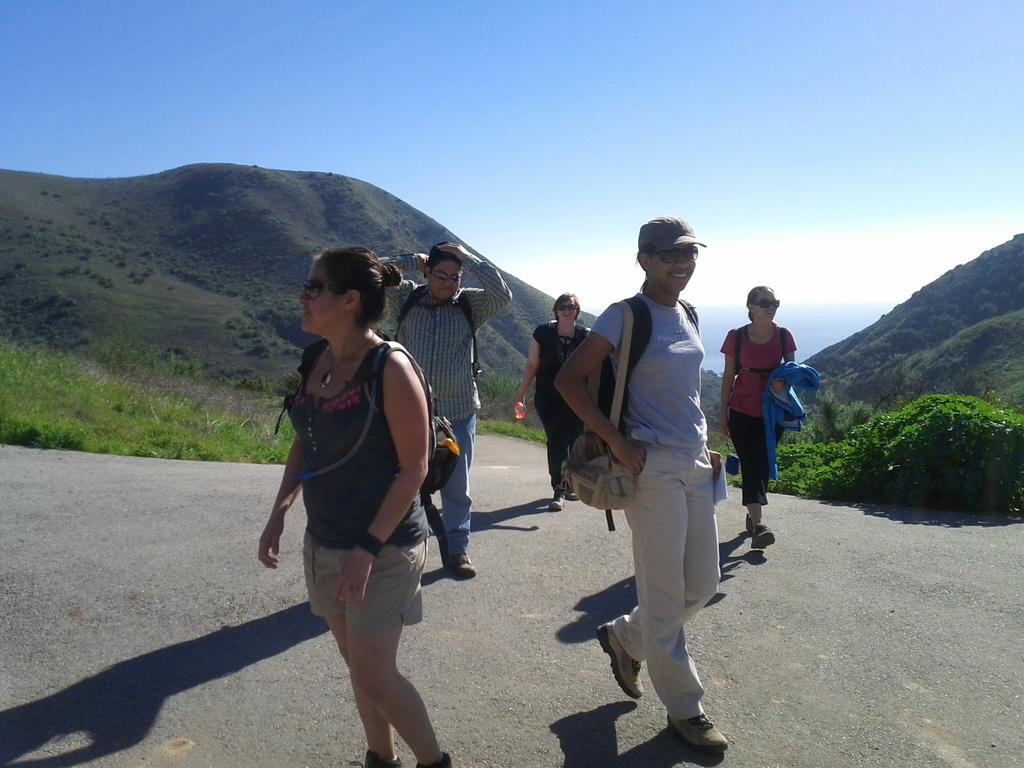How many people are in the image? There is a group of people in the image. What are the people doing in the image? The people are walking on a road. What can be seen in the background of the image? There are planets and mountains visible in the background of the image. What type of pipe can be seen in the hands of the people walking on the road? There is no pipe present in the image; the people are simply walking on a road. 